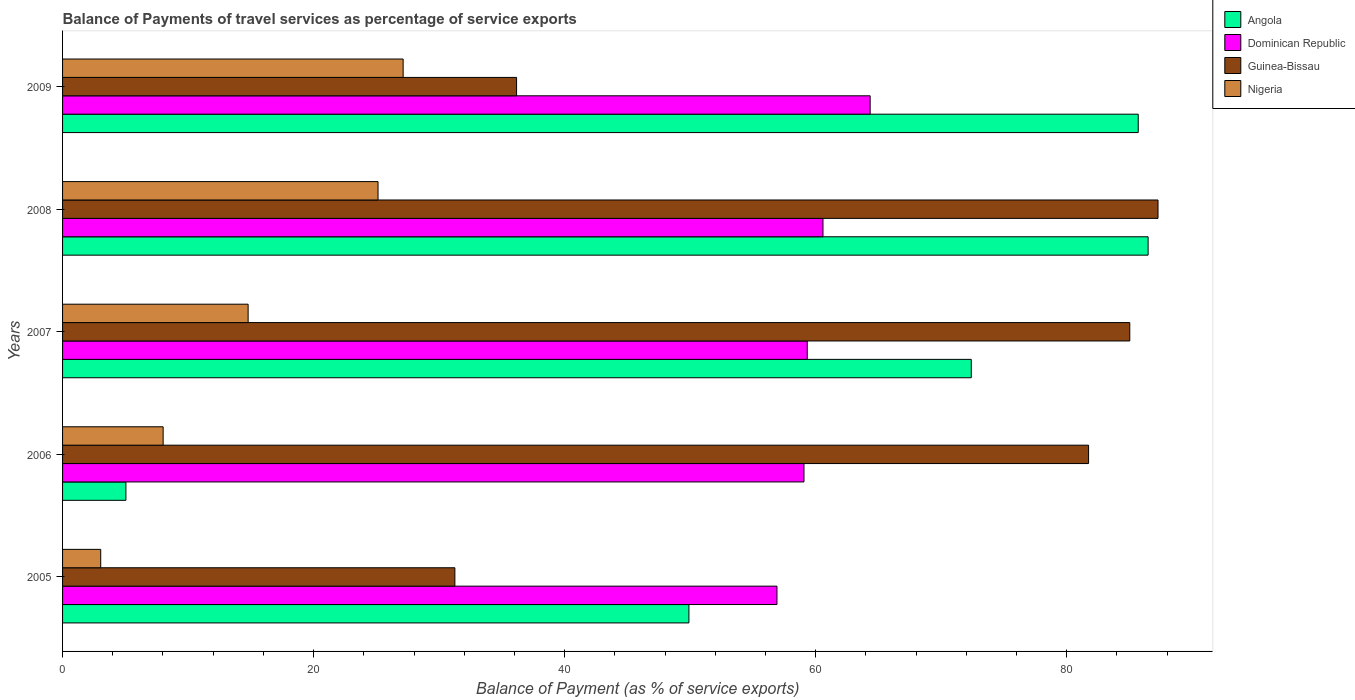Are the number of bars on each tick of the Y-axis equal?
Your answer should be very brief. Yes. How many bars are there on the 5th tick from the top?
Ensure brevity in your answer.  4. How many bars are there on the 3rd tick from the bottom?
Give a very brief answer. 4. What is the label of the 5th group of bars from the top?
Keep it short and to the point. 2005. What is the balance of payments of travel services in Angola in 2005?
Give a very brief answer. 49.9. Across all years, what is the maximum balance of payments of travel services in Dominican Republic?
Your answer should be very brief. 64.34. Across all years, what is the minimum balance of payments of travel services in Dominican Republic?
Your answer should be very brief. 56.92. In which year was the balance of payments of travel services in Angola maximum?
Keep it short and to the point. 2008. In which year was the balance of payments of travel services in Dominican Republic minimum?
Your response must be concise. 2005. What is the total balance of payments of travel services in Angola in the graph?
Your answer should be very brief. 299.53. What is the difference between the balance of payments of travel services in Angola in 2005 and that in 2008?
Make the answer very short. -36.58. What is the difference between the balance of payments of travel services in Guinea-Bissau in 2005 and the balance of payments of travel services in Angola in 2007?
Keep it short and to the point. -41.14. What is the average balance of payments of travel services in Nigeria per year?
Ensure brevity in your answer.  15.62. In the year 2008, what is the difference between the balance of payments of travel services in Angola and balance of payments of travel services in Dominican Republic?
Offer a terse response. 25.9. In how many years, is the balance of payments of travel services in Angola greater than 60 %?
Provide a succinct answer. 3. What is the ratio of the balance of payments of travel services in Angola in 2005 to that in 2008?
Provide a succinct answer. 0.58. Is the balance of payments of travel services in Guinea-Bissau in 2006 less than that in 2007?
Offer a very short reply. Yes. What is the difference between the highest and the second highest balance of payments of travel services in Angola?
Your response must be concise. 0.79. What is the difference between the highest and the lowest balance of payments of travel services in Angola?
Provide a succinct answer. 81.44. In how many years, is the balance of payments of travel services in Guinea-Bissau greater than the average balance of payments of travel services in Guinea-Bissau taken over all years?
Your answer should be compact. 3. Is the sum of the balance of payments of travel services in Nigeria in 2007 and 2008 greater than the maximum balance of payments of travel services in Dominican Republic across all years?
Ensure brevity in your answer.  No. What does the 2nd bar from the top in 2007 represents?
Make the answer very short. Guinea-Bissau. What does the 4th bar from the bottom in 2007 represents?
Your answer should be compact. Nigeria. Is it the case that in every year, the sum of the balance of payments of travel services in Dominican Republic and balance of payments of travel services in Guinea-Bissau is greater than the balance of payments of travel services in Nigeria?
Offer a terse response. Yes. Are all the bars in the graph horizontal?
Provide a short and direct response. Yes. What is the difference between two consecutive major ticks on the X-axis?
Ensure brevity in your answer.  20. Where does the legend appear in the graph?
Give a very brief answer. Top right. What is the title of the graph?
Provide a succinct answer. Balance of Payments of travel services as percentage of service exports. What is the label or title of the X-axis?
Give a very brief answer. Balance of Payment (as % of service exports). What is the label or title of the Y-axis?
Keep it short and to the point. Years. What is the Balance of Payment (as % of service exports) in Angola in 2005?
Keep it short and to the point. 49.9. What is the Balance of Payment (as % of service exports) of Dominican Republic in 2005?
Give a very brief answer. 56.92. What is the Balance of Payment (as % of service exports) in Guinea-Bissau in 2005?
Ensure brevity in your answer.  31.25. What is the Balance of Payment (as % of service exports) of Nigeria in 2005?
Offer a very short reply. 3.04. What is the Balance of Payment (as % of service exports) in Angola in 2006?
Make the answer very short. 5.05. What is the Balance of Payment (as % of service exports) in Dominican Republic in 2006?
Your response must be concise. 59.07. What is the Balance of Payment (as % of service exports) of Guinea-Bissau in 2006?
Your response must be concise. 81.74. What is the Balance of Payment (as % of service exports) in Nigeria in 2006?
Offer a terse response. 8.01. What is the Balance of Payment (as % of service exports) of Angola in 2007?
Your response must be concise. 72.4. What is the Balance of Payment (as % of service exports) of Dominican Republic in 2007?
Your answer should be compact. 59.33. What is the Balance of Payment (as % of service exports) of Guinea-Bissau in 2007?
Give a very brief answer. 85.03. What is the Balance of Payment (as % of service exports) of Nigeria in 2007?
Keep it short and to the point. 14.78. What is the Balance of Payment (as % of service exports) in Angola in 2008?
Your answer should be compact. 86.48. What is the Balance of Payment (as % of service exports) of Dominican Republic in 2008?
Make the answer very short. 60.58. What is the Balance of Payment (as % of service exports) of Guinea-Bissau in 2008?
Provide a succinct answer. 87.27. What is the Balance of Payment (as % of service exports) of Nigeria in 2008?
Your response must be concise. 25.13. What is the Balance of Payment (as % of service exports) of Angola in 2009?
Your answer should be very brief. 85.7. What is the Balance of Payment (as % of service exports) in Dominican Republic in 2009?
Provide a short and direct response. 64.34. What is the Balance of Payment (as % of service exports) of Guinea-Bissau in 2009?
Provide a succinct answer. 36.17. What is the Balance of Payment (as % of service exports) of Nigeria in 2009?
Provide a succinct answer. 27.13. Across all years, what is the maximum Balance of Payment (as % of service exports) in Angola?
Provide a short and direct response. 86.48. Across all years, what is the maximum Balance of Payment (as % of service exports) of Dominican Republic?
Offer a terse response. 64.34. Across all years, what is the maximum Balance of Payment (as % of service exports) of Guinea-Bissau?
Keep it short and to the point. 87.27. Across all years, what is the maximum Balance of Payment (as % of service exports) of Nigeria?
Your response must be concise. 27.13. Across all years, what is the minimum Balance of Payment (as % of service exports) of Angola?
Your answer should be compact. 5.05. Across all years, what is the minimum Balance of Payment (as % of service exports) of Dominican Republic?
Your answer should be compact. 56.92. Across all years, what is the minimum Balance of Payment (as % of service exports) of Guinea-Bissau?
Offer a terse response. 31.25. Across all years, what is the minimum Balance of Payment (as % of service exports) of Nigeria?
Your answer should be compact. 3.04. What is the total Balance of Payment (as % of service exports) in Angola in the graph?
Your answer should be compact. 299.53. What is the total Balance of Payment (as % of service exports) in Dominican Republic in the graph?
Your answer should be compact. 300.24. What is the total Balance of Payment (as % of service exports) in Guinea-Bissau in the graph?
Your answer should be compact. 321.47. What is the total Balance of Payment (as % of service exports) in Nigeria in the graph?
Offer a very short reply. 78.1. What is the difference between the Balance of Payment (as % of service exports) of Angola in 2005 and that in 2006?
Offer a terse response. 44.85. What is the difference between the Balance of Payment (as % of service exports) in Dominican Republic in 2005 and that in 2006?
Ensure brevity in your answer.  -2.15. What is the difference between the Balance of Payment (as % of service exports) in Guinea-Bissau in 2005 and that in 2006?
Make the answer very short. -50.49. What is the difference between the Balance of Payment (as % of service exports) of Nigeria in 2005 and that in 2006?
Provide a succinct answer. -4.97. What is the difference between the Balance of Payment (as % of service exports) of Angola in 2005 and that in 2007?
Your answer should be very brief. -22.5. What is the difference between the Balance of Payment (as % of service exports) in Dominican Republic in 2005 and that in 2007?
Your answer should be very brief. -2.41. What is the difference between the Balance of Payment (as % of service exports) of Guinea-Bissau in 2005 and that in 2007?
Your response must be concise. -53.77. What is the difference between the Balance of Payment (as % of service exports) in Nigeria in 2005 and that in 2007?
Give a very brief answer. -11.74. What is the difference between the Balance of Payment (as % of service exports) of Angola in 2005 and that in 2008?
Offer a very short reply. -36.59. What is the difference between the Balance of Payment (as % of service exports) in Dominican Republic in 2005 and that in 2008?
Give a very brief answer. -3.67. What is the difference between the Balance of Payment (as % of service exports) in Guinea-Bissau in 2005 and that in 2008?
Offer a terse response. -56.02. What is the difference between the Balance of Payment (as % of service exports) of Nigeria in 2005 and that in 2008?
Give a very brief answer. -22.09. What is the difference between the Balance of Payment (as % of service exports) of Angola in 2005 and that in 2009?
Provide a short and direct response. -35.8. What is the difference between the Balance of Payment (as % of service exports) of Dominican Republic in 2005 and that in 2009?
Offer a very short reply. -7.42. What is the difference between the Balance of Payment (as % of service exports) in Guinea-Bissau in 2005 and that in 2009?
Give a very brief answer. -4.92. What is the difference between the Balance of Payment (as % of service exports) of Nigeria in 2005 and that in 2009?
Your response must be concise. -24.09. What is the difference between the Balance of Payment (as % of service exports) in Angola in 2006 and that in 2007?
Provide a succinct answer. -67.35. What is the difference between the Balance of Payment (as % of service exports) in Dominican Republic in 2006 and that in 2007?
Your response must be concise. -0.26. What is the difference between the Balance of Payment (as % of service exports) of Guinea-Bissau in 2006 and that in 2007?
Your answer should be very brief. -3.28. What is the difference between the Balance of Payment (as % of service exports) in Nigeria in 2006 and that in 2007?
Offer a terse response. -6.77. What is the difference between the Balance of Payment (as % of service exports) in Angola in 2006 and that in 2008?
Make the answer very short. -81.44. What is the difference between the Balance of Payment (as % of service exports) of Dominican Republic in 2006 and that in 2008?
Give a very brief answer. -1.51. What is the difference between the Balance of Payment (as % of service exports) of Guinea-Bissau in 2006 and that in 2008?
Ensure brevity in your answer.  -5.53. What is the difference between the Balance of Payment (as % of service exports) of Nigeria in 2006 and that in 2008?
Keep it short and to the point. -17.12. What is the difference between the Balance of Payment (as % of service exports) of Angola in 2006 and that in 2009?
Provide a succinct answer. -80.65. What is the difference between the Balance of Payment (as % of service exports) in Dominican Republic in 2006 and that in 2009?
Provide a succinct answer. -5.27. What is the difference between the Balance of Payment (as % of service exports) of Guinea-Bissau in 2006 and that in 2009?
Your answer should be compact. 45.57. What is the difference between the Balance of Payment (as % of service exports) in Nigeria in 2006 and that in 2009?
Provide a succinct answer. -19.12. What is the difference between the Balance of Payment (as % of service exports) of Angola in 2007 and that in 2008?
Offer a very short reply. -14.09. What is the difference between the Balance of Payment (as % of service exports) in Dominican Republic in 2007 and that in 2008?
Ensure brevity in your answer.  -1.25. What is the difference between the Balance of Payment (as % of service exports) of Guinea-Bissau in 2007 and that in 2008?
Provide a succinct answer. -2.25. What is the difference between the Balance of Payment (as % of service exports) in Nigeria in 2007 and that in 2008?
Give a very brief answer. -10.35. What is the difference between the Balance of Payment (as % of service exports) in Angola in 2007 and that in 2009?
Make the answer very short. -13.3. What is the difference between the Balance of Payment (as % of service exports) in Dominican Republic in 2007 and that in 2009?
Make the answer very short. -5.01. What is the difference between the Balance of Payment (as % of service exports) of Guinea-Bissau in 2007 and that in 2009?
Your answer should be compact. 48.85. What is the difference between the Balance of Payment (as % of service exports) of Nigeria in 2007 and that in 2009?
Offer a very short reply. -12.35. What is the difference between the Balance of Payment (as % of service exports) of Angola in 2008 and that in 2009?
Provide a succinct answer. 0.79. What is the difference between the Balance of Payment (as % of service exports) of Dominican Republic in 2008 and that in 2009?
Ensure brevity in your answer.  -3.76. What is the difference between the Balance of Payment (as % of service exports) of Guinea-Bissau in 2008 and that in 2009?
Your response must be concise. 51.1. What is the difference between the Balance of Payment (as % of service exports) of Nigeria in 2008 and that in 2009?
Make the answer very short. -2. What is the difference between the Balance of Payment (as % of service exports) of Angola in 2005 and the Balance of Payment (as % of service exports) of Dominican Republic in 2006?
Your response must be concise. -9.17. What is the difference between the Balance of Payment (as % of service exports) of Angola in 2005 and the Balance of Payment (as % of service exports) of Guinea-Bissau in 2006?
Ensure brevity in your answer.  -31.84. What is the difference between the Balance of Payment (as % of service exports) in Angola in 2005 and the Balance of Payment (as % of service exports) in Nigeria in 2006?
Provide a short and direct response. 41.89. What is the difference between the Balance of Payment (as % of service exports) in Dominican Republic in 2005 and the Balance of Payment (as % of service exports) in Guinea-Bissau in 2006?
Your answer should be compact. -24.83. What is the difference between the Balance of Payment (as % of service exports) of Dominican Republic in 2005 and the Balance of Payment (as % of service exports) of Nigeria in 2006?
Your answer should be very brief. 48.9. What is the difference between the Balance of Payment (as % of service exports) in Guinea-Bissau in 2005 and the Balance of Payment (as % of service exports) in Nigeria in 2006?
Make the answer very short. 23.24. What is the difference between the Balance of Payment (as % of service exports) of Angola in 2005 and the Balance of Payment (as % of service exports) of Dominican Republic in 2007?
Ensure brevity in your answer.  -9.43. What is the difference between the Balance of Payment (as % of service exports) in Angola in 2005 and the Balance of Payment (as % of service exports) in Guinea-Bissau in 2007?
Your answer should be compact. -35.13. What is the difference between the Balance of Payment (as % of service exports) of Angola in 2005 and the Balance of Payment (as % of service exports) of Nigeria in 2007?
Provide a succinct answer. 35.12. What is the difference between the Balance of Payment (as % of service exports) in Dominican Republic in 2005 and the Balance of Payment (as % of service exports) in Guinea-Bissau in 2007?
Ensure brevity in your answer.  -28.11. What is the difference between the Balance of Payment (as % of service exports) in Dominican Republic in 2005 and the Balance of Payment (as % of service exports) in Nigeria in 2007?
Provide a succinct answer. 42.13. What is the difference between the Balance of Payment (as % of service exports) in Guinea-Bissau in 2005 and the Balance of Payment (as % of service exports) in Nigeria in 2007?
Offer a very short reply. 16.47. What is the difference between the Balance of Payment (as % of service exports) of Angola in 2005 and the Balance of Payment (as % of service exports) of Dominican Republic in 2008?
Provide a succinct answer. -10.68. What is the difference between the Balance of Payment (as % of service exports) in Angola in 2005 and the Balance of Payment (as % of service exports) in Guinea-Bissau in 2008?
Offer a very short reply. -37.37. What is the difference between the Balance of Payment (as % of service exports) of Angola in 2005 and the Balance of Payment (as % of service exports) of Nigeria in 2008?
Ensure brevity in your answer.  24.77. What is the difference between the Balance of Payment (as % of service exports) of Dominican Republic in 2005 and the Balance of Payment (as % of service exports) of Guinea-Bissau in 2008?
Give a very brief answer. -30.36. What is the difference between the Balance of Payment (as % of service exports) of Dominican Republic in 2005 and the Balance of Payment (as % of service exports) of Nigeria in 2008?
Ensure brevity in your answer.  31.78. What is the difference between the Balance of Payment (as % of service exports) in Guinea-Bissau in 2005 and the Balance of Payment (as % of service exports) in Nigeria in 2008?
Your answer should be very brief. 6.12. What is the difference between the Balance of Payment (as % of service exports) in Angola in 2005 and the Balance of Payment (as % of service exports) in Dominican Republic in 2009?
Offer a very short reply. -14.44. What is the difference between the Balance of Payment (as % of service exports) in Angola in 2005 and the Balance of Payment (as % of service exports) in Guinea-Bissau in 2009?
Your response must be concise. 13.73. What is the difference between the Balance of Payment (as % of service exports) in Angola in 2005 and the Balance of Payment (as % of service exports) in Nigeria in 2009?
Make the answer very short. 22.77. What is the difference between the Balance of Payment (as % of service exports) of Dominican Republic in 2005 and the Balance of Payment (as % of service exports) of Guinea-Bissau in 2009?
Provide a succinct answer. 20.75. What is the difference between the Balance of Payment (as % of service exports) of Dominican Republic in 2005 and the Balance of Payment (as % of service exports) of Nigeria in 2009?
Ensure brevity in your answer.  29.78. What is the difference between the Balance of Payment (as % of service exports) in Guinea-Bissau in 2005 and the Balance of Payment (as % of service exports) in Nigeria in 2009?
Provide a succinct answer. 4.12. What is the difference between the Balance of Payment (as % of service exports) of Angola in 2006 and the Balance of Payment (as % of service exports) of Dominican Republic in 2007?
Offer a very short reply. -54.28. What is the difference between the Balance of Payment (as % of service exports) of Angola in 2006 and the Balance of Payment (as % of service exports) of Guinea-Bissau in 2007?
Your answer should be compact. -79.98. What is the difference between the Balance of Payment (as % of service exports) in Angola in 2006 and the Balance of Payment (as % of service exports) in Nigeria in 2007?
Give a very brief answer. -9.74. What is the difference between the Balance of Payment (as % of service exports) in Dominican Republic in 2006 and the Balance of Payment (as % of service exports) in Guinea-Bissau in 2007?
Keep it short and to the point. -25.96. What is the difference between the Balance of Payment (as % of service exports) in Dominican Republic in 2006 and the Balance of Payment (as % of service exports) in Nigeria in 2007?
Give a very brief answer. 44.29. What is the difference between the Balance of Payment (as % of service exports) in Guinea-Bissau in 2006 and the Balance of Payment (as % of service exports) in Nigeria in 2007?
Offer a terse response. 66.96. What is the difference between the Balance of Payment (as % of service exports) in Angola in 2006 and the Balance of Payment (as % of service exports) in Dominican Republic in 2008?
Your response must be concise. -55.54. What is the difference between the Balance of Payment (as % of service exports) of Angola in 2006 and the Balance of Payment (as % of service exports) of Guinea-Bissau in 2008?
Make the answer very short. -82.23. What is the difference between the Balance of Payment (as % of service exports) of Angola in 2006 and the Balance of Payment (as % of service exports) of Nigeria in 2008?
Your answer should be compact. -20.09. What is the difference between the Balance of Payment (as % of service exports) of Dominican Republic in 2006 and the Balance of Payment (as % of service exports) of Guinea-Bissau in 2008?
Make the answer very short. -28.21. What is the difference between the Balance of Payment (as % of service exports) in Dominican Republic in 2006 and the Balance of Payment (as % of service exports) in Nigeria in 2008?
Keep it short and to the point. 33.94. What is the difference between the Balance of Payment (as % of service exports) in Guinea-Bissau in 2006 and the Balance of Payment (as % of service exports) in Nigeria in 2008?
Your answer should be very brief. 56.61. What is the difference between the Balance of Payment (as % of service exports) of Angola in 2006 and the Balance of Payment (as % of service exports) of Dominican Republic in 2009?
Keep it short and to the point. -59.29. What is the difference between the Balance of Payment (as % of service exports) in Angola in 2006 and the Balance of Payment (as % of service exports) in Guinea-Bissau in 2009?
Offer a terse response. -31.12. What is the difference between the Balance of Payment (as % of service exports) of Angola in 2006 and the Balance of Payment (as % of service exports) of Nigeria in 2009?
Keep it short and to the point. -22.09. What is the difference between the Balance of Payment (as % of service exports) of Dominican Republic in 2006 and the Balance of Payment (as % of service exports) of Guinea-Bissau in 2009?
Your response must be concise. 22.9. What is the difference between the Balance of Payment (as % of service exports) of Dominican Republic in 2006 and the Balance of Payment (as % of service exports) of Nigeria in 2009?
Ensure brevity in your answer.  31.94. What is the difference between the Balance of Payment (as % of service exports) of Guinea-Bissau in 2006 and the Balance of Payment (as % of service exports) of Nigeria in 2009?
Ensure brevity in your answer.  54.61. What is the difference between the Balance of Payment (as % of service exports) in Angola in 2007 and the Balance of Payment (as % of service exports) in Dominican Republic in 2008?
Offer a very short reply. 11.81. What is the difference between the Balance of Payment (as % of service exports) in Angola in 2007 and the Balance of Payment (as % of service exports) in Guinea-Bissau in 2008?
Make the answer very short. -14.88. What is the difference between the Balance of Payment (as % of service exports) in Angola in 2007 and the Balance of Payment (as % of service exports) in Nigeria in 2008?
Offer a terse response. 47.26. What is the difference between the Balance of Payment (as % of service exports) in Dominican Republic in 2007 and the Balance of Payment (as % of service exports) in Guinea-Bissau in 2008?
Give a very brief answer. -27.95. What is the difference between the Balance of Payment (as % of service exports) of Dominican Republic in 2007 and the Balance of Payment (as % of service exports) of Nigeria in 2008?
Give a very brief answer. 34.2. What is the difference between the Balance of Payment (as % of service exports) in Guinea-Bissau in 2007 and the Balance of Payment (as % of service exports) in Nigeria in 2008?
Ensure brevity in your answer.  59.89. What is the difference between the Balance of Payment (as % of service exports) in Angola in 2007 and the Balance of Payment (as % of service exports) in Dominican Republic in 2009?
Give a very brief answer. 8.06. What is the difference between the Balance of Payment (as % of service exports) of Angola in 2007 and the Balance of Payment (as % of service exports) of Guinea-Bissau in 2009?
Give a very brief answer. 36.23. What is the difference between the Balance of Payment (as % of service exports) of Angola in 2007 and the Balance of Payment (as % of service exports) of Nigeria in 2009?
Your response must be concise. 45.26. What is the difference between the Balance of Payment (as % of service exports) of Dominican Republic in 2007 and the Balance of Payment (as % of service exports) of Guinea-Bissau in 2009?
Give a very brief answer. 23.16. What is the difference between the Balance of Payment (as % of service exports) in Dominican Republic in 2007 and the Balance of Payment (as % of service exports) in Nigeria in 2009?
Provide a short and direct response. 32.2. What is the difference between the Balance of Payment (as % of service exports) of Guinea-Bissau in 2007 and the Balance of Payment (as % of service exports) of Nigeria in 2009?
Your answer should be compact. 57.89. What is the difference between the Balance of Payment (as % of service exports) of Angola in 2008 and the Balance of Payment (as % of service exports) of Dominican Republic in 2009?
Your response must be concise. 22.14. What is the difference between the Balance of Payment (as % of service exports) of Angola in 2008 and the Balance of Payment (as % of service exports) of Guinea-Bissau in 2009?
Give a very brief answer. 50.31. What is the difference between the Balance of Payment (as % of service exports) of Angola in 2008 and the Balance of Payment (as % of service exports) of Nigeria in 2009?
Give a very brief answer. 59.35. What is the difference between the Balance of Payment (as % of service exports) in Dominican Republic in 2008 and the Balance of Payment (as % of service exports) in Guinea-Bissau in 2009?
Your answer should be very brief. 24.41. What is the difference between the Balance of Payment (as % of service exports) of Dominican Republic in 2008 and the Balance of Payment (as % of service exports) of Nigeria in 2009?
Give a very brief answer. 33.45. What is the difference between the Balance of Payment (as % of service exports) in Guinea-Bissau in 2008 and the Balance of Payment (as % of service exports) in Nigeria in 2009?
Provide a short and direct response. 60.14. What is the average Balance of Payment (as % of service exports) of Angola per year?
Offer a terse response. 59.91. What is the average Balance of Payment (as % of service exports) in Dominican Republic per year?
Your answer should be compact. 60.05. What is the average Balance of Payment (as % of service exports) in Guinea-Bissau per year?
Your response must be concise. 64.29. What is the average Balance of Payment (as % of service exports) in Nigeria per year?
Make the answer very short. 15.62. In the year 2005, what is the difference between the Balance of Payment (as % of service exports) in Angola and Balance of Payment (as % of service exports) in Dominican Republic?
Make the answer very short. -7.02. In the year 2005, what is the difference between the Balance of Payment (as % of service exports) in Angola and Balance of Payment (as % of service exports) in Guinea-Bissau?
Give a very brief answer. 18.65. In the year 2005, what is the difference between the Balance of Payment (as % of service exports) of Angola and Balance of Payment (as % of service exports) of Nigeria?
Provide a short and direct response. 46.86. In the year 2005, what is the difference between the Balance of Payment (as % of service exports) in Dominican Republic and Balance of Payment (as % of service exports) in Guinea-Bissau?
Keep it short and to the point. 25.66. In the year 2005, what is the difference between the Balance of Payment (as % of service exports) in Dominican Republic and Balance of Payment (as % of service exports) in Nigeria?
Provide a short and direct response. 53.88. In the year 2005, what is the difference between the Balance of Payment (as % of service exports) in Guinea-Bissau and Balance of Payment (as % of service exports) in Nigeria?
Offer a very short reply. 28.22. In the year 2006, what is the difference between the Balance of Payment (as % of service exports) of Angola and Balance of Payment (as % of service exports) of Dominican Republic?
Give a very brief answer. -54.02. In the year 2006, what is the difference between the Balance of Payment (as % of service exports) of Angola and Balance of Payment (as % of service exports) of Guinea-Bissau?
Provide a short and direct response. -76.7. In the year 2006, what is the difference between the Balance of Payment (as % of service exports) of Angola and Balance of Payment (as % of service exports) of Nigeria?
Give a very brief answer. -2.97. In the year 2006, what is the difference between the Balance of Payment (as % of service exports) of Dominican Republic and Balance of Payment (as % of service exports) of Guinea-Bissau?
Your answer should be very brief. -22.67. In the year 2006, what is the difference between the Balance of Payment (as % of service exports) in Dominican Republic and Balance of Payment (as % of service exports) in Nigeria?
Keep it short and to the point. 51.06. In the year 2006, what is the difference between the Balance of Payment (as % of service exports) of Guinea-Bissau and Balance of Payment (as % of service exports) of Nigeria?
Your answer should be compact. 73.73. In the year 2007, what is the difference between the Balance of Payment (as % of service exports) of Angola and Balance of Payment (as % of service exports) of Dominican Republic?
Keep it short and to the point. 13.07. In the year 2007, what is the difference between the Balance of Payment (as % of service exports) of Angola and Balance of Payment (as % of service exports) of Guinea-Bissau?
Provide a succinct answer. -12.63. In the year 2007, what is the difference between the Balance of Payment (as % of service exports) of Angola and Balance of Payment (as % of service exports) of Nigeria?
Your answer should be compact. 57.61. In the year 2007, what is the difference between the Balance of Payment (as % of service exports) of Dominican Republic and Balance of Payment (as % of service exports) of Guinea-Bissau?
Offer a terse response. -25.7. In the year 2007, what is the difference between the Balance of Payment (as % of service exports) of Dominican Republic and Balance of Payment (as % of service exports) of Nigeria?
Offer a very short reply. 44.55. In the year 2007, what is the difference between the Balance of Payment (as % of service exports) of Guinea-Bissau and Balance of Payment (as % of service exports) of Nigeria?
Make the answer very short. 70.24. In the year 2008, what is the difference between the Balance of Payment (as % of service exports) in Angola and Balance of Payment (as % of service exports) in Dominican Republic?
Your response must be concise. 25.9. In the year 2008, what is the difference between the Balance of Payment (as % of service exports) in Angola and Balance of Payment (as % of service exports) in Guinea-Bissau?
Your answer should be very brief. -0.79. In the year 2008, what is the difference between the Balance of Payment (as % of service exports) in Angola and Balance of Payment (as % of service exports) in Nigeria?
Your answer should be very brief. 61.35. In the year 2008, what is the difference between the Balance of Payment (as % of service exports) of Dominican Republic and Balance of Payment (as % of service exports) of Guinea-Bissau?
Give a very brief answer. -26.69. In the year 2008, what is the difference between the Balance of Payment (as % of service exports) in Dominican Republic and Balance of Payment (as % of service exports) in Nigeria?
Offer a terse response. 35.45. In the year 2008, what is the difference between the Balance of Payment (as % of service exports) of Guinea-Bissau and Balance of Payment (as % of service exports) of Nigeria?
Offer a very short reply. 62.14. In the year 2009, what is the difference between the Balance of Payment (as % of service exports) of Angola and Balance of Payment (as % of service exports) of Dominican Republic?
Your answer should be very brief. 21.36. In the year 2009, what is the difference between the Balance of Payment (as % of service exports) in Angola and Balance of Payment (as % of service exports) in Guinea-Bissau?
Your answer should be very brief. 49.53. In the year 2009, what is the difference between the Balance of Payment (as % of service exports) in Angola and Balance of Payment (as % of service exports) in Nigeria?
Provide a succinct answer. 58.57. In the year 2009, what is the difference between the Balance of Payment (as % of service exports) in Dominican Republic and Balance of Payment (as % of service exports) in Guinea-Bissau?
Your answer should be very brief. 28.17. In the year 2009, what is the difference between the Balance of Payment (as % of service exports) in Dominican Republic and Balance of Payment (as % of service exports) in Nigeria?
Keep it short and to the point. 37.21. In the year 2009, what is the difference between the Balance of Payment (as % of service exports) of Guinea-Bissau and Balance of Payment (as % of service exports) of Nigeria?
Make the answer very short. 9.04. What is the ratio of the Balance of Payment (as % of service exports) in Angola in 2005 to that in 2006?
Keep it short and to the point. 9.89. What is the ratio of the Balance of Payment (as % of service exports) in Dominican Republic in 2005 to that in 2006?
Make the answer very short. 0.96. What is the ratio of the Balance of Payment (as % of service exports) in Guinea-Bissau in 2005 to that in 2006?
Offer a terse response. 0.38. What is the ratio of the Balance of Payment (as % of service exports) of Nigeria in 2005 to that in 2006?
Provide a succinct answer. 0.38. What is the ratio of the Balance of Payment (as % of service exports) of Angola in 2005 to that in 2007?
Give a very brief answer. 0.69. What is the ratio of the Balance of Payment (as % of service exports) of Dominican Republic in 2005 to that in 2007?
Offer a terse response. 0.96. What is the ratio of the Balance of Payment (as % of service exports) of Guinea-Bissau in 2005 to that in 2007?
Make the answer very short. 0.37. What is the ratio of the Balance of Payment (as % of service exports) in Nigeria in 2005 to that in 2007?
Your answer should be compact. 0.21. What is the ratio of the Balance of Payment (as % of service exports) of Angola in 2005 to that in 2008?
Ensure brevity in your answer.  0.58. What is the ratio of the Balance of Payment (as % of service exports) of Dominican Republic in 2005 to that in 2008?
Make the answer very short. 0.94. What is the ratio of the Balance of Payment (as % of service exports) of Guinea-Bissau in 2005 to that in 2008?
Provide a succinct answer. 0.36. What is the ratio of the Balance of Payment (as % of service exports) in Nigeria in 2005 to that in 2008?
Your answer should be compact. 0.12. What is the ratio of the Balance of Payment (as % of service exports) in Angola in 2005 to that in 2009?
Offer a very short reply. 0.58. What is the ratio of the Balance of Payment (as % of service exports) in Dominican Republic in 2005 to that in 2009?
Your answer should be compact. 0.88. What is the ratio of the Balance of Payment (as % of service exports) in Guinea-Bissau in 2005 to that in 2009?
Keep it short and to the point. 0.86. What is the ratio of the Balance of Payment (as % of service exports) in Nigeria in 2005 to that in 2009?
Your answer should be compact. 0.11. What is the ratio of the Balance of Payment (as % of service exports) in Angola in 2006 to that in 2007?
Provide a succinct answer. 0.07. What is the ratio of the Balance of Payment (as % of service exports) of Dominican Republic in 2006 to that in 2007?
Provide a succinct answer. 1. What is the ratio of the Balance of Payment (as % of service exports) in Guinea-Bissau in 2006 to that in 2007?
Your answer should be compact. 0.96. What is the ratio of the Balance of Payment (as % of service exports) in Nigeria in 2006 to that in 2007?
Your response must be concise. 0.54. What is the ratio of the Balance of Payment (as % of service exports) in Angola in 2006 to that in 2008?
Your response must be concise. 0.06. What is the ratio of the Balance of Payment (as % of service exports) of Guinea-Bissau in 2006 to that in 2008?
Provide a succinct answer. 0.94. What is the ratio of the Balance of Payment (as % of service exports) in Nigeria in 2006 to that in 2008?
Provide a short and direct response. 0.32. What is the ratio of the Balance of Payment (as % of service exports) of Angola in 2006 to that in 2009?
Your answer should be compact. 0.06. What is the ratio of the Balance of Payment (as % of service exports) in Dominican Republic in 2006 to that in 2009?
Offer a terse response. 0.92. What is the ratio of the Balance of Payment (as % of service exports) of Guinea-Bissau in 2006 to that in 2009?
Your answer should be compact. 2.26. What is the ratio of the Balance of Payment (as % of service exports) of Nigeria in 2006 to that in 2009?
Provide a short and direct response. 0.3. What is the ratio of the Balance of Payment (as % of service exports) of Angola in 2007 to that in 2008?
Your answer should be compact. 0.84. What is the ratio of the Balance of Payment (as % of service exports) of Dominican Republic in 2007 to that in 2008?
Provide a short and direct response. 0.98. What is the ratio of the Balance of Payment (as % of service exports) in Guinea-Bissau in 2007 to that in 2008?
Make the answer very short. 0.97. What is the ratio of the Balance of Payment (as % of service exports) of Nigeria in 2007 to that in 2008?
Your response must be concise. 0.59. What is the ratio of the Balance of Payment (as % of service exports) of Angola in 2007 to that in 2009?
Your response must be concise. 0.84. What is the ratio of the Balance of Payment (as % of service exports) of Dominican Republic in 2007 to that in 2009?
Provide a short and direct response. 0.92. What is the ratio of the Balance of Payment (as % of service exports) in Guinea-Bissau in 2007 to that in 2009?
Provide a succinct answer. 2.35. What is the ratio of the Balance of Payment (as % of service exports) of Nigeria in 2007 to that in 2009?
Offer a terse response. 0.54. What is the ratio of the Balance of Payment (as % of service exports) of Angola in 2008 to that in 2009?
Offer a terse response. 1.01. What is the ratio of the Balance of Payment (as % of service exports) in Dominican Republic in 2008 to that in 2009?
Provide a succinct answer. 0.94. What is the ratio of the Balance of Payment (as % of service exports) of Guinea-Bissau in 2008 to that in 2009?
Keep it short and to the point. 2.41. What is the ratio of the Balance of Payment (as % of service exports) in Nigeria in 2008 to that in 2009?
Keep it short and to the point. 0.93. What is the difference between the highest and the second highest Balance of Payment (as % of service exports) of Angola?
Your answer should be compact. 0.79. What is the difference between the highest and the second highest Balance of Payment (as % of service exports) of Dominican Republic?
Ensure brevity in your answer.  3.76. What is the difference between the highest and the second highest Balance of Payment (as % of service exports) of Guinea-Bissau?
Your response must be concise. 2.25. What is the difference between the highest and the second highest Balance of Payment (as % of service exports) of Nigeria?
Offer a very short reply. 2. What is the difference between the highest and the lowest Balance of Payment (as % of service exports) of Angola?
Offer a very short reply. 81.44. What is the difference between the highest and the lowest Balance of Payment (as % of service exports) in Dominican Republic?
Make the answer very short. 7.42. What is the difference between the highest and the lowest Balance of Payment (as % of service exports) in Guinea-Bissau?
Offer a very short reply. 56.02. What is the difference between the highest and the lowest Balance of Payment (as % of service exports) of Nigeria?
Offer a terse response. 24.09. 